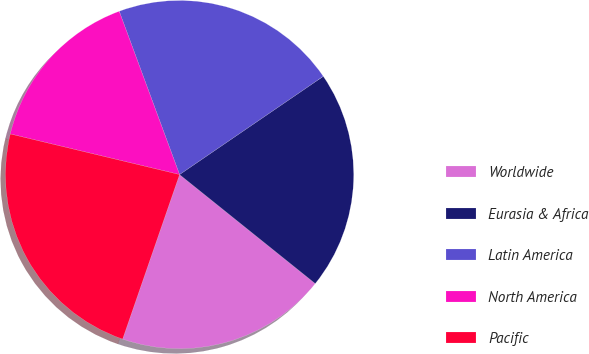Convert chart. <chart><loc_0><loc_0><loc_500><loc_500><pie_chart><fcel>Worldwide<fcel>Eurasia & Africa<fcel>Latin America<fcel>North America<fcel>Pacific<nl><fcel>19.53%<fcel>20.31%<fcel>21.09%<fcel>15.62%<fcel>23.44%<nl></chart> 